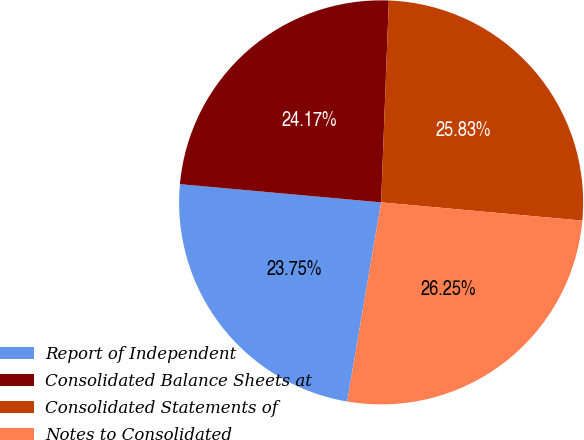Convert chart. <chart><loc_0><loc_0><loc_500><loc_500><pie_chart><fcel>Report of Independent<fcel>Consolidated Balance Sheets at<fcel>Consolidated Statements of<fcel>Notes to Consolidated<nl><fcel>23.75%<fcel>24.17%<fcel>25.83%<fcel>26.25%<nl></chart> 